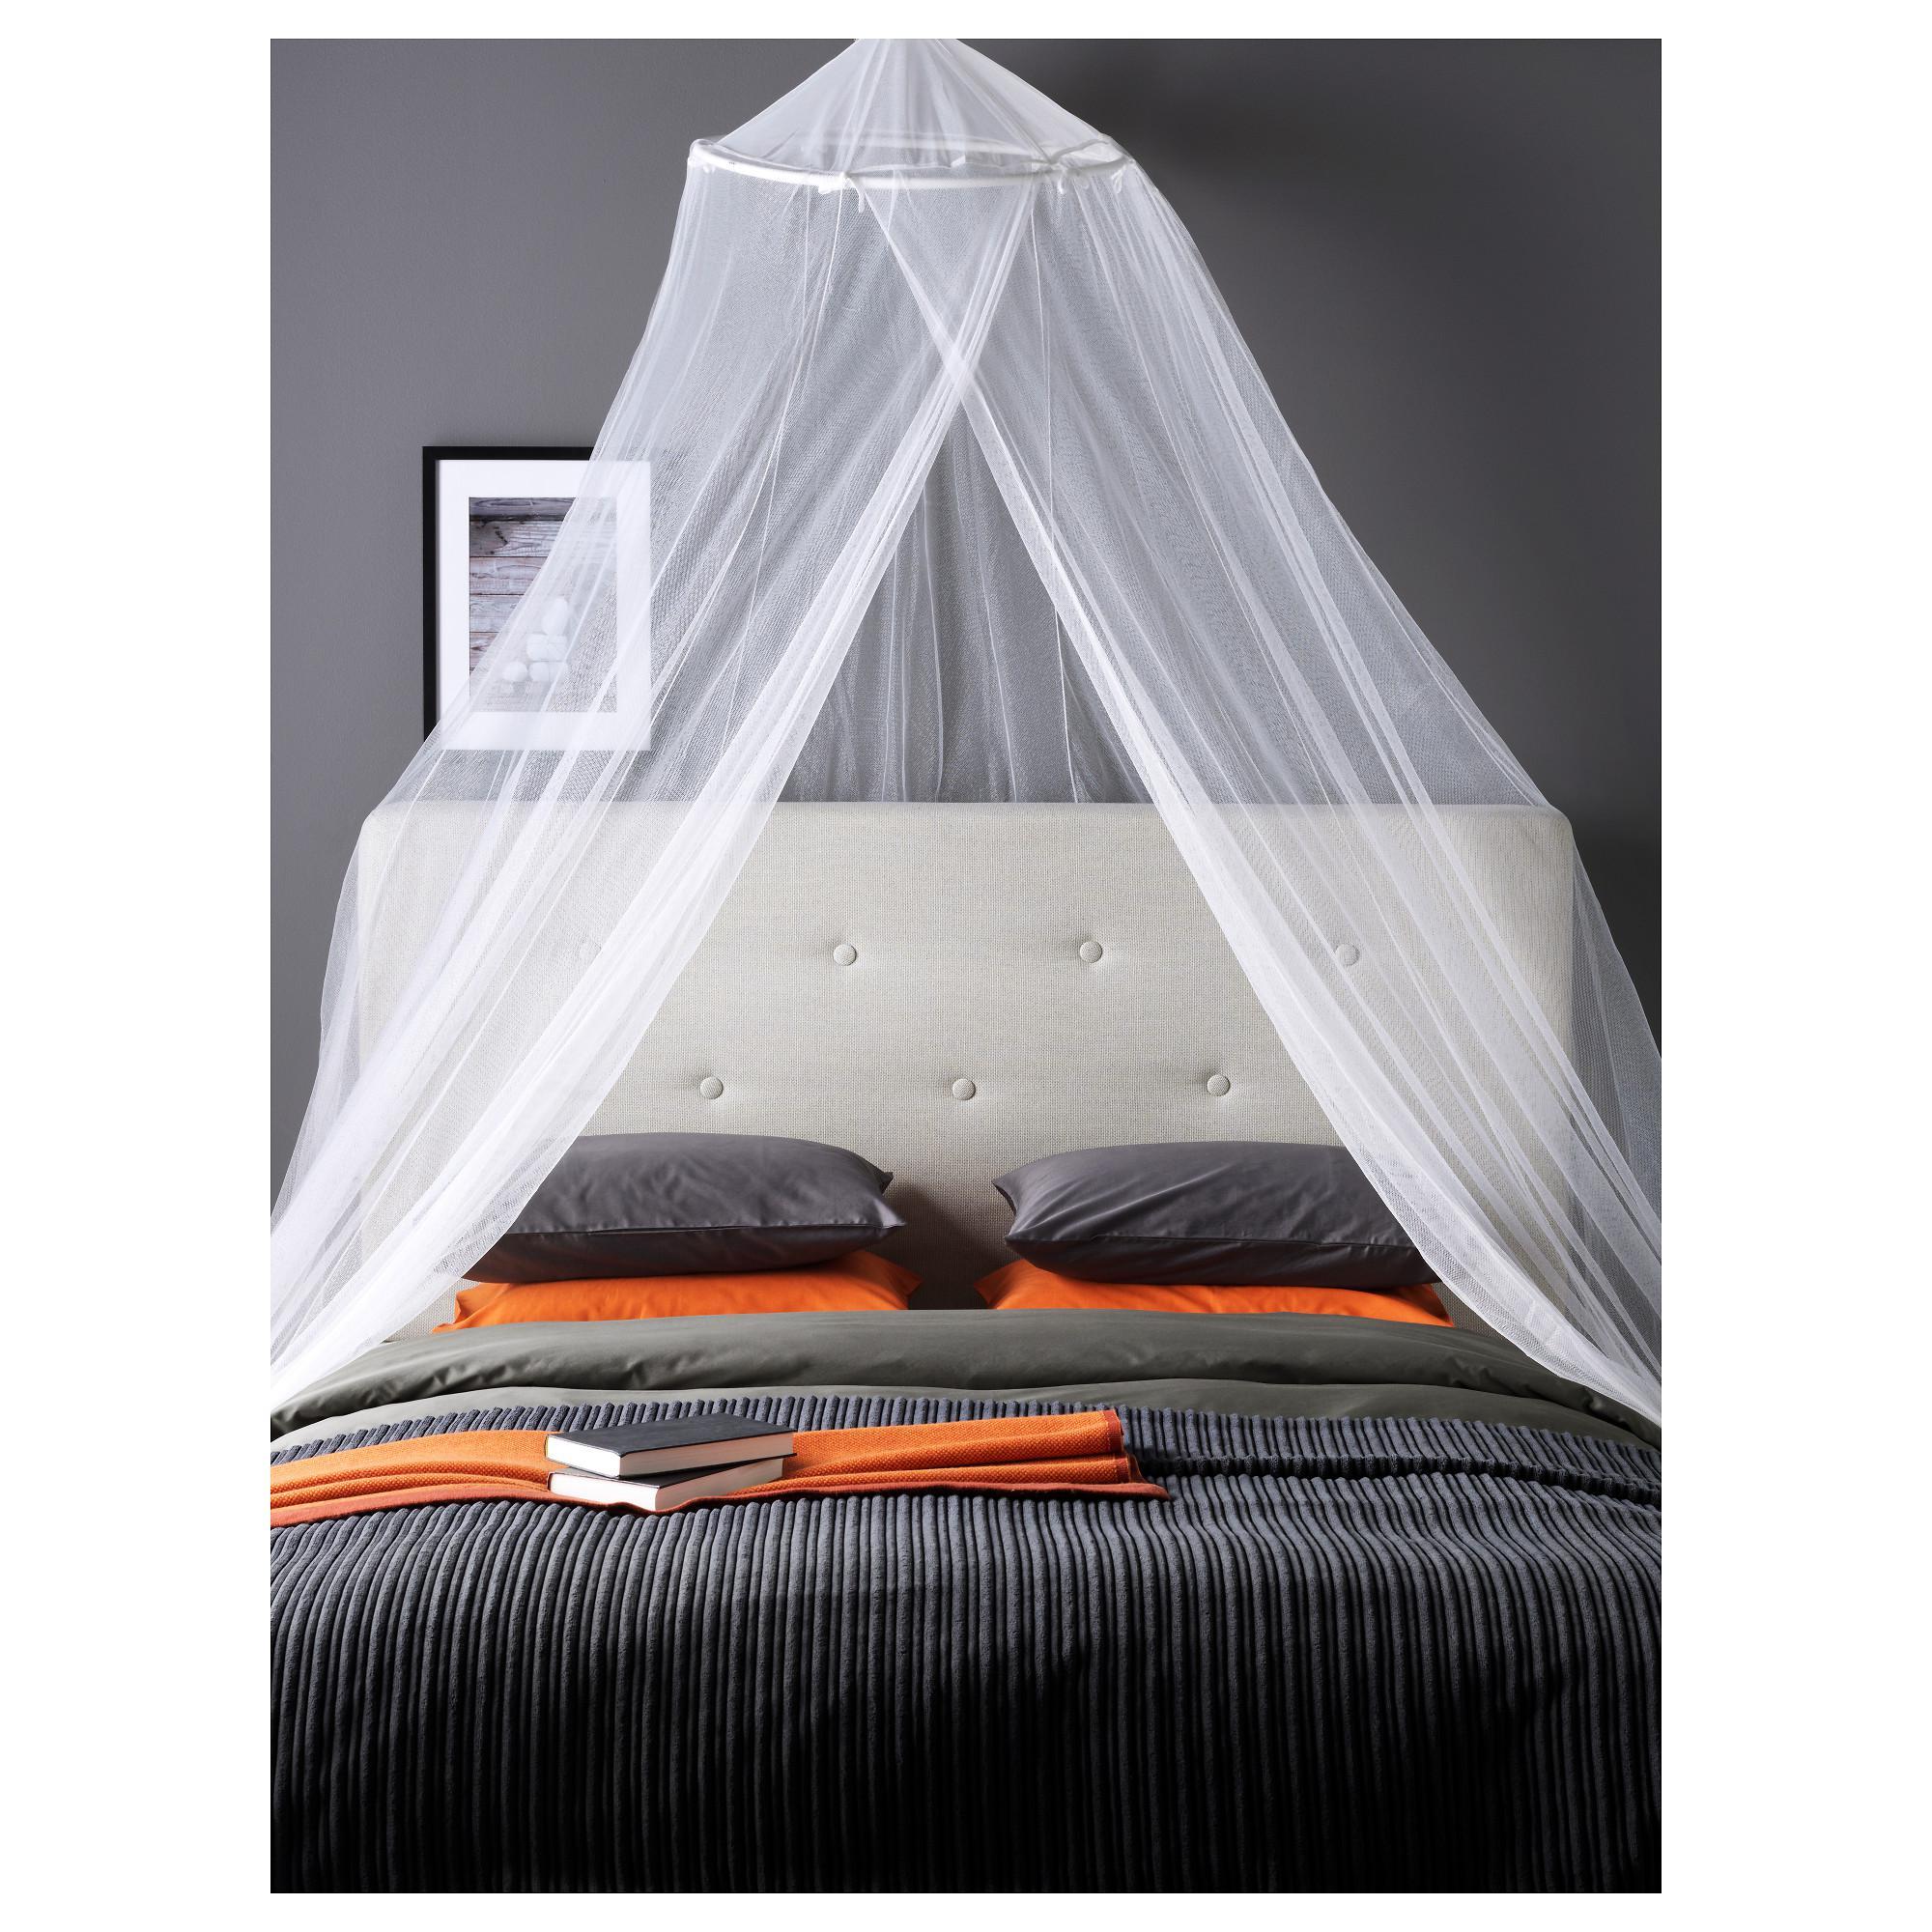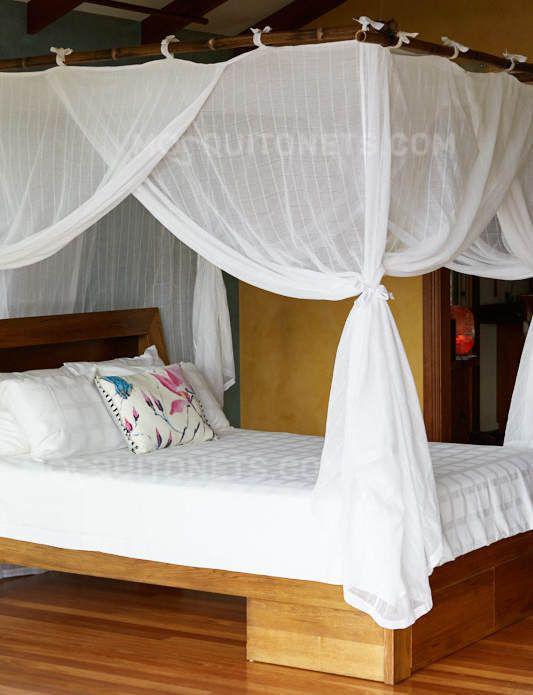The first image is the image on the left, the second image is the image on the right. For the images displayed, is the sentence "There is at least one child in each bed." factually correct? Answer yes or no. No. The first image is the image on the left, the second image is the image on the right. Assess this claim about the two images: "There are two canopies with at least two child.". Correct or not? Answer yes or no. No. 